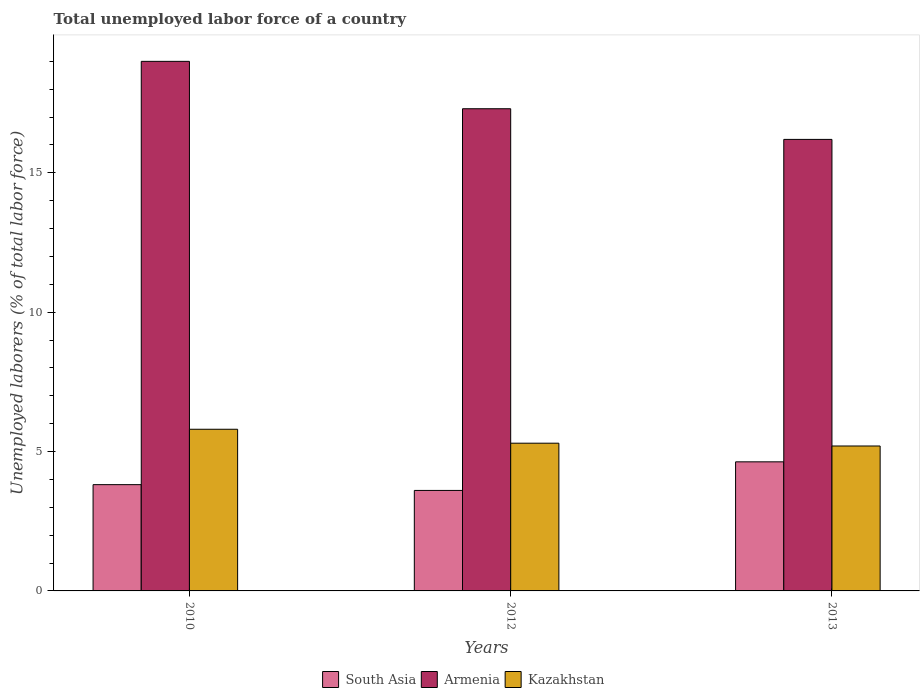How many different coloured bars are there?
Keep it short and to the point. 3. How many groups of bars are there?
Your answer should be compact. 3. Are the number of bars on each tick of the X-axis equal?
Provide a short and direct response. Yes. How many bars are there on the 1st tick from the left?
Offer a very short reply. 3. What is the label of the 1st group of bars from the left?
Offer a very short reply. 2010. What is the total unemployed labor force in Kazakhstan in 2013?
Offer a very short reply. 5.2. Across all years, what is the minimum total unemployed labor force in Armenia?
Your answer should be very brief. 16.2. In which year was the total unemployed labor force in South Asia maximum?
Your answer should be very brief. 2013. In which year was the total unemployed labor force in South Asia minimum?
Your answer should be compact. 2012. What is the total total unemployed labor force in Armenia in the graph?
Offer a terse response. 52.5. What is the difference between the total unemployed labor force in Armenia in 2010 and that in 2013?
Offer a very short reply. 2.8. What is the difference between the total unemployed labor force in South Asia in 2010 and the total unemployed labor force in Armenia in 2013?
Offer a terse response. -12.39. What is the average total unemployed labor force in South Asia per year?
Provide a succinct answer. 4.02. In the year 2010, what is the difference between the total unemployed labor force in Armenia and total unemployed labor force in Kazakhstan?
Your answer should be very brief. 13.2. What is the ratio of the total unemployed labor force in Armenia in 2010 to that in 2012?
Make the answer very short. 1.1. Is the total unemployed labor force in Armenia in 2010 less than that in 2013?
Ensure brevity in your answer.  No. Is the difference between the total unemployed labor force in Armenia in 2010 and 2012 greater than the difference between the total unemployed labor force in Kazakhstan in 2010 and 2012?
Keep it short and to the point. Yes. What is the difference between the highest and the second highest total unemployed labor force in Armenia?
Keep it short and to the point. 1.7. What is the difference between the highest and the lowest total unemployed labor force in South Asia?
Offer a terse response. 1.03. Is the sum of the total unemployed labor force in South Asia in 2010 and 2012 greater than the maximum total unemployed labor force in Kazakhstan across all years?
Keep it short and to the point. Yes. What does the 2nd bar from the left in 2010 represents?
Provide a succinct answer. Armenia. Is it the case that in every year, the sum of the total unemployed labor force in South Asia and total unemployed labor force in Armenia is greater than the total unemployed labor force in Kazakhstan?
Your response must be concise. Yes. Are all the bars in the graph horizontal?
Your answer should be very brief. No. Does the graph contain any zero values?
Give a very brief answer. No. How many legend labels are there?
Provide a succinct answer. 3. What is the title of the graph?
Provide a short and direct response. Total unemployed labor force of a country. What is the label or title of the X-axis?
Your answer should be compact. Years. What is the label or title of the Y-axis?
Provide a succinct answer. Unemployed laborers (% of total labor force). What is the Unemployed laborers (% of total labor force) of South Asia in 2010?
Your answer should be compact. 3.81. What is the Unemployed laborers (% of total labor force) in Kazakhstan in 2010?
Keep it short and to the point. 5.8. What is the Unemployed laborers (% of total labor force) in South Asia in 2012?
Provide a succinct answer. 3.61. What is the Unemployed laborers (% of total labor force) of Armenia in 2012?
Offer a terse response. 17.3. What is the Unemployed laborers (% of total labor force) in Kazakhstan in 2012?
Your response must be concise. 5.3. What is the Unemployed laborers (% of total labor force) in South Asia in 2013?
Your response must be concise. 4.63. What is the Unemployed laborers (% of total labor force) of Armenia in 2013?
Make the answer very short. 16.2. What is the Unemployed laborers (% of total labor force) of Kazakhstan in 2013?
Ensure brevity in your answer.  5.2. Across all years, what is the maximum Unemployed laborers (% of total labor force) of South Asia?
Provide a succinct answer. 4.63. Across all years, what is the maximum Unemployed laborers (% of total labor force) in Kazakhstan?
Your answer should be compact. 5.8. Across all years, what is the minimum Unemployed laborers (% of total labor force) of South Asia?
Give a very brief answer. 3.61. Across all years, what is the minimum Unemployed laborers (% of total labor force) of Armenia?
Offer a terse response. 16.2. Across all years, what is the minimum Unemployed laborers (% of total labor force) in Kazakhstan?
Your response must be concise. 5.2. What is the total Unemployed laborers (% of total labor force) of South Asia in the graph?
Give a very brief answer. 12.05. What is the total Unemployed laborers (% of total labor force) of Armenia in the graph?
Provide a succinct answer. 52.5. What is the total Unemployed laborers (% of total labor force) in Kazakhstan in the graph?
Make the answer very short. 16.3. What is the difference between the Unemployed laborers (% of total labor force) in South Asia in 2010 and that in 2012?
Your response must be concise. 0.21. What is the difference between the Unemployed laborers (% of total labor force) of Armenia in 2010 and that in 2012?
Give a very brief answer. 1.7. What is the difference between the Unemployed laborers (% of total labor force) of Kazakhstan in 2010 and that in 2012?
Make the answer very short. 0.5. What is the difference between the Unemployed laborers (% of total labor force) in South Asia in 2010 and that in 2013?
Provide a succinct answer. -0.82. What is the difference between the Unemployed laborers (% of total labor force) of South Asia in 2012 and that in 2013?
Ensure brevity in your answer.  -1.03. What is the difference between the Unemployed laborers (% of total labor force) of Armenia in 2012 and that in 2013?
Offer a terse response. 1.1. What is the difference between the Unemployed laborers (% of total labor force) in South Asia in 2010 and the Unemployed laborers (% of total labor force) in Armenia in 2012?
Your response must be concise. -13.49. What is the difference between the Unemployed laborers (% of total labor force) of South Asia in 2010 and the Unemployed laborers (% of total labor force) of Kazakhstan in 2012?
Your answer should be compact. -1.49. What is the difference between the Unemployed laborers (% of total labor force) in South Asia in 2010 and the Unemployed laborers (% of total labor force) in Armenia in 2013?
Keep it short and to the point. -12.39. What is the difference between the Unemployed laborers (% of total labor force) of South Asia in 2010 and the Unemployed laborers (% of total labor force) of Kazakhstan in 2013?
Offer a very short reply. -1.39. What is the difference between the Unemployed laborers (% of total labor force) in South Asia in 2012 and the Unemployed laborers (% of total labor force) in Armenia in 2013?
Your response must be concise. -12.59. What is the difference between the Unemployed laborers (% of total labor force) in South Asia in 2012 and the Unemployed laborers (% of total labor force) in Kazakhstan in 2013?
Provide a succinct answer. -1.59. What is the difference between the Unemployed laborers (% of total labor force) in Armenia in 2012 and the Unemployed laborers (% of total labor force) in Kazakhstan in 2013?
Provide a succinct answer. 12.1. What is the average Unemployed laborers (% of total labor force) in South Asia per year?
Your response must be concise. 4.02. What is the average Unemployed laborers (% of total labor force) in Armenia per year?
Offer a terse response. 17.5. What is the average Unemployed laborers (% of total labor force) in Kazakhstan per year?
Your answer should be very brief. 5.43. In the year 2010, what is the difference between the Unemployed laborers (% of total labor force) of South Asia and Unemployed laborers (% of total labor force) of Armenia?
Ensure brevity in your answer.  -15.19. In the year 2010, what is the difference between the Unemployed laborers (% of total labor force) in South Asia and Unemployed laborers (% of total labor force) in Kazakhstan?
Your answer should be very brief. -1.99. In the year 2012, what is the difference between the Unemployed laborers (% of total labor force) of South Asia and Unemployed laborers (% of total labor force) of Armenia?
Your answer should be very brief. -13.69. In the year 2012, what is the difference between the Unemployed laborers (% of total labor force) in South Asia and Unemployed laborers (% of total labor force) in Kazakhstan?
Your response must be concise. -1.69. In the year 2013, what is the difference between the Unemployed laborers (% of total labor force) of South Asia and Unemployed laborers (% of total labor force) of Armenia?
Offer a very short reply. -11.57. In the year 2013, what is the difference between the Unemployed laborers (% of total labor force) in South Asia and Unemployed laborers (% of total labor force) in Kazakhstan?
Your response must be concise. -0.57. In the year 2013, what is the difference between the Unemployed laborers (% of total labor force) in Armenia and Unemployed laborers (% of total labor force) in Kazakhstan?
Offer a terse response. 11. What is the ratio of the Unemployed laborers (% of total labor force) of South Asia in 2010 to that in 2012?
Your answer should be compact. 1.06. What is the ratio of the Unemployed laborers (% of total labor force) of Armenia in 2010 to that in 2012?
Make the answer very short. 1.1. What is the ratio of the Unemployed laborers (% of total labor force) in Kazakhstan in 2010 to that in 2012?
Make the answer very short. 1.09. What is the ratio of the Unemployed laborers (% of total labor force) in South Asia in 2010 to that in 2013?
Make the answer very short. 0.82. What is the ratio of the Unemployed laborers (% of total labor force) in Armenia in 2010 to that in 2013?
Your answer should be compact. 1.17. What is the ratio of the Unemployed laborers (% of total labor force) in Kazakhstan in 2010 to that in 2013?
Give a very brief answer. 1.12. What is the ratio of the Unemployed laborers (% of total labor force) of South Asia in 2012 to that in 2013?
Your answer should be very brief. 0.78. What is the ratio of the Unemployed laborers (% of total labor force) in Armenia in 2012 to that in 2013?
Provide a succinct answer. 1.07. What is the ratio of the Unemployed laborers (% of total labor force) of Kazakhstan in 2012 to that in 2013?
Offer a very short reply. 1.02. What is the difference between the highest and the second highest Unemployed laborers (% of total labor force) in South Asia?
Offer a terse response. 0.82. What is the difference between the highest and the second highest Unemployed laborers (% of total labor force) of Kazakhstan?
Keep it short and to the point. 0.5. What is the difference between the highest and the lowest Unemployed laborers (% of total labor force) in South Asia?
Keep it short and to the point. 1.03. What is the difference between the highest and the lowest Unemployed laborers (% of total labor force) in Kazakhstan?
Your response must be concise. 0.6. 